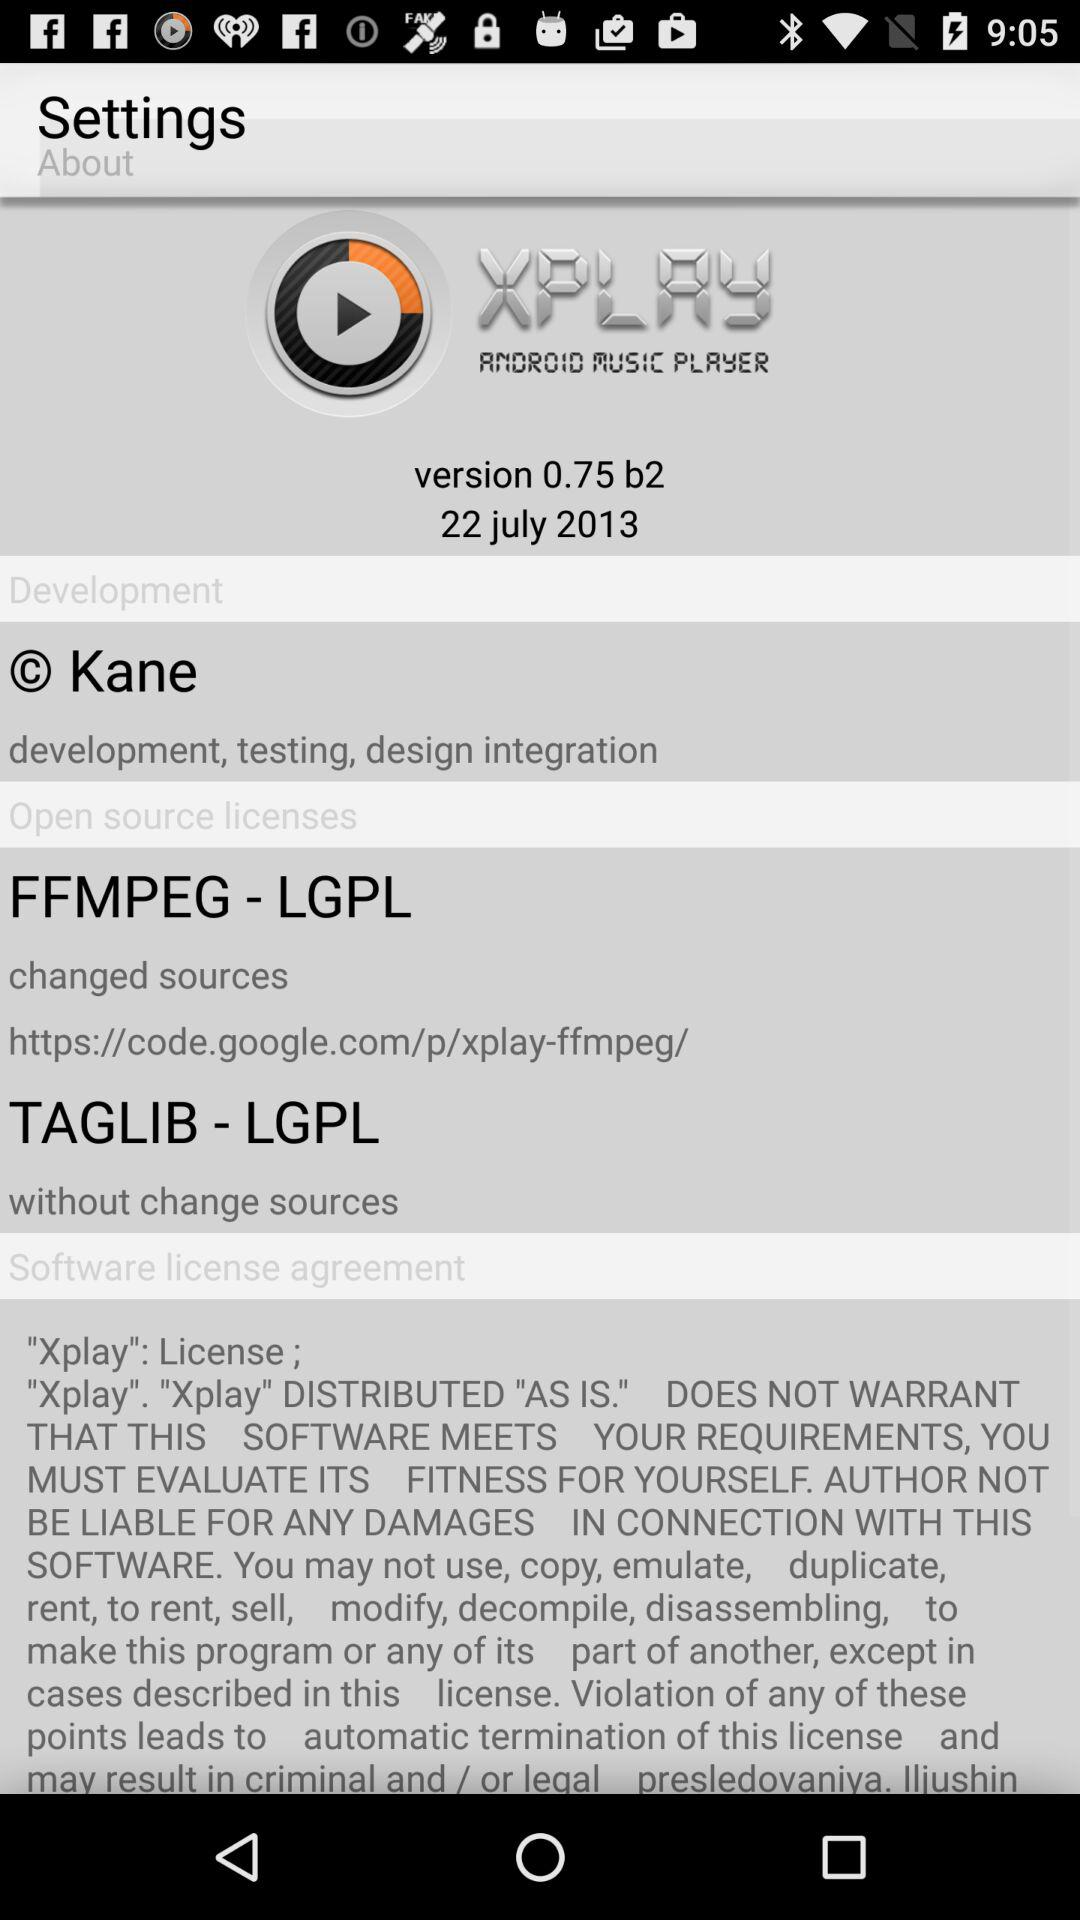On what date was the version released? The version was released on July 22, 2013. 